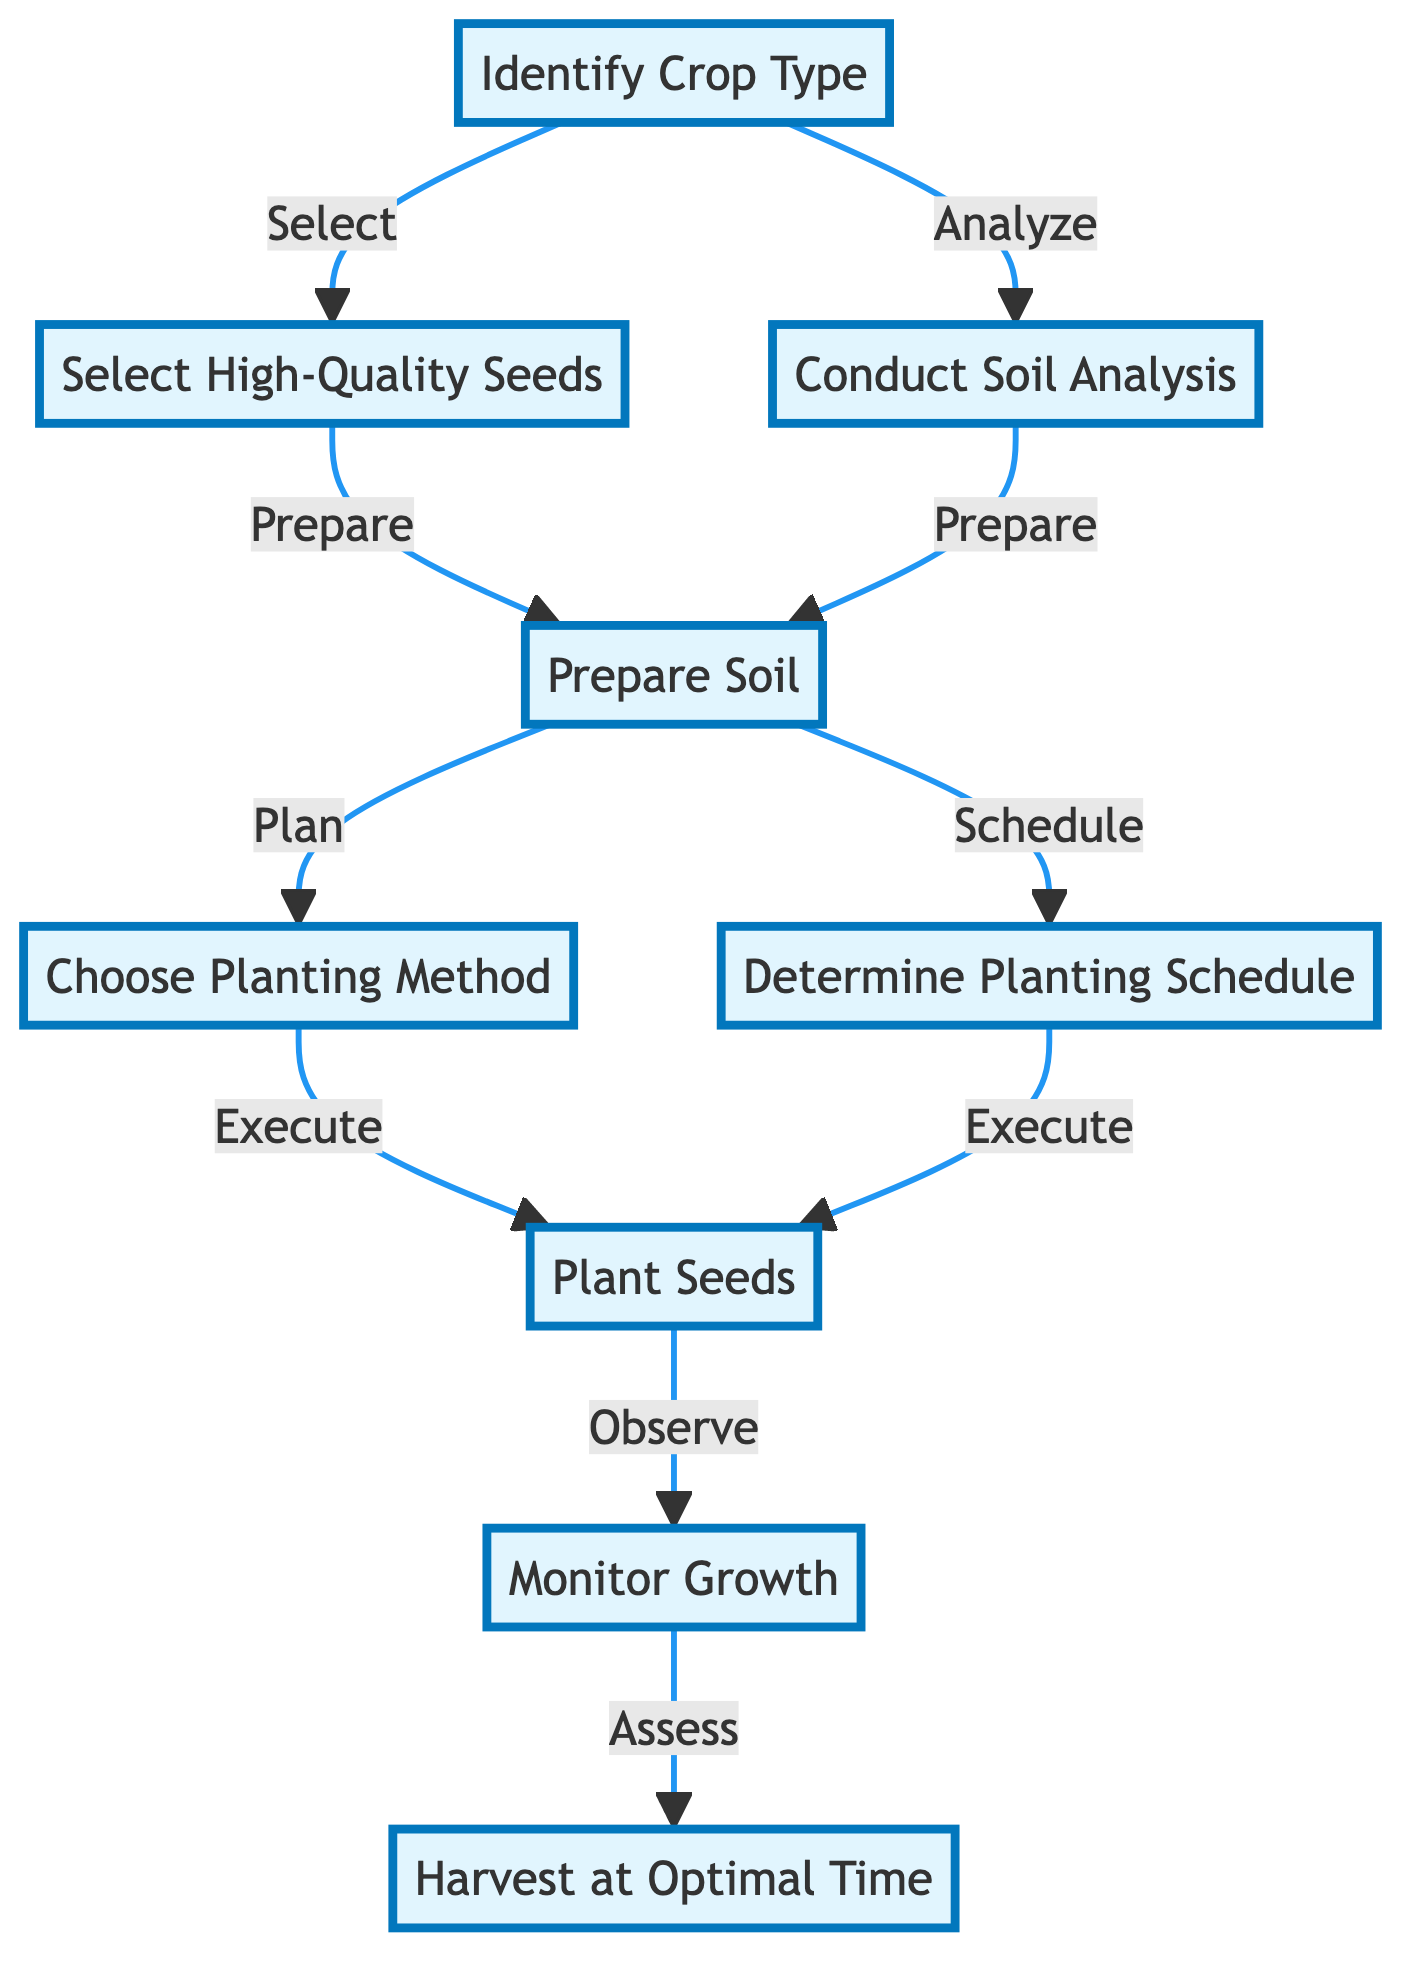What is the first step in the process? The first step is "Identify Crop Type," as indicated at the top of the flow chart. This shows that before any other actions can be taken, determining the target crop is essential.
Answer: Identify Crop Type How many main steps are there in the process? By counting the nodes, there are a total of eight main steps in the process, from "Identify Crop Type" to "Harvest at Optimal Time."
Answer: Eight What follows after "Select High-Quality Seeds"? After "Select High-Quality Seeds," the next step involves conducting a soil analysis as the diagram shows an arrow leading to "Conduct Soil Analysis."
Answer: Conduct Soil Analysis Which steps are executed simultaneously after preparing the soil? The steps "Choose Planting Method" and "Determine Planting Schedule" follow "Prepare Soil" and are both connected to it, indicating that they occur simultaneously.
Answer: Choose Planting Method, Determine Planting Schedule What is observed after planting the seeds? After planting the seeds, the process calls for "Monitor Growth," as indicated by the arrow leading from "Plant Seeds" to "Monitor Growth."
Answer: Monitor Growth How many steps are there between planting seeds and harvesting? There are two steps: "Monitor Growth" and "Harvest at Optimal Time," which can be counted from the arrow leading from "Plant Seeds."
Answer: Two What is the last action described in the flow chart? The last action in the flow chart is "Harvest at Optimal Time," which is at the bottom and indicates the conclusion of the planting process.
Answer: Harvest at Optimal Time Which step involves determining planting dates? The step that involves determining planting dates is "Determine Planting Schedule," as indicated in the diagram.
Answer: Determine Planting Schedule What action must be taken before choosing a planting method? Prior to choosing a planting method, the action "Prepare Soil" must be completed, as shown by the connection from "Prepare Soil" to "Choose Planting Method."
Answer: Prepare Soil 